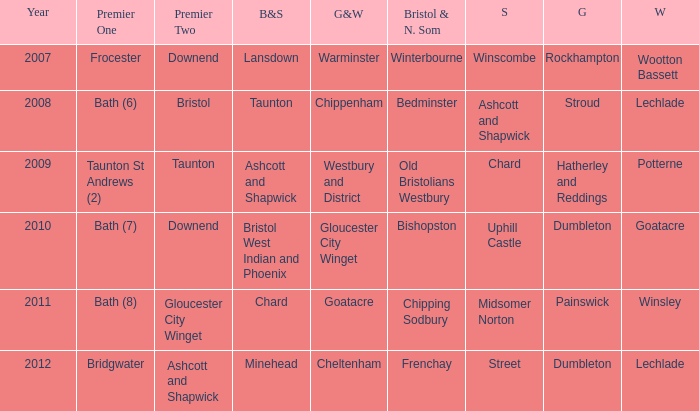What is the latest year where glos & wilts is warminster? 2007.0. 